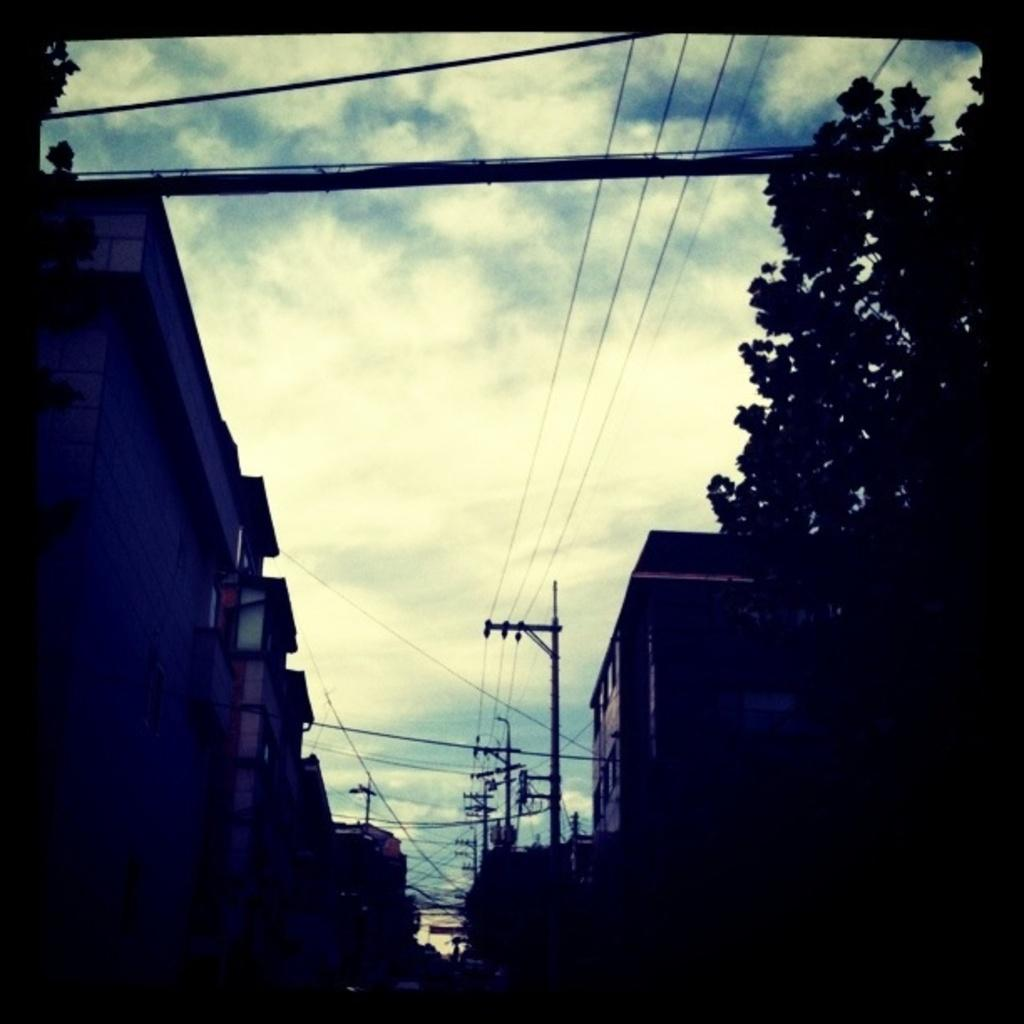What is the overall appearance of the image? The image has a dark appearance. What type of structures can be seen in the image? There are buildings in the image. What other natural elements are present in the image? There are trees in the image. What infrastructure elements are visible in the image? Current poles and wires are present in the image. What part of the natural environment is visible in the image? The sky is visible in the image. Can you tell me how many family members are sitting on the seat in the image? There is no family or seat present in the image. What type of operation is being performed on the current pole in the image? There is no operation being performed on the current pole in the image; it is simply a stationary object. 